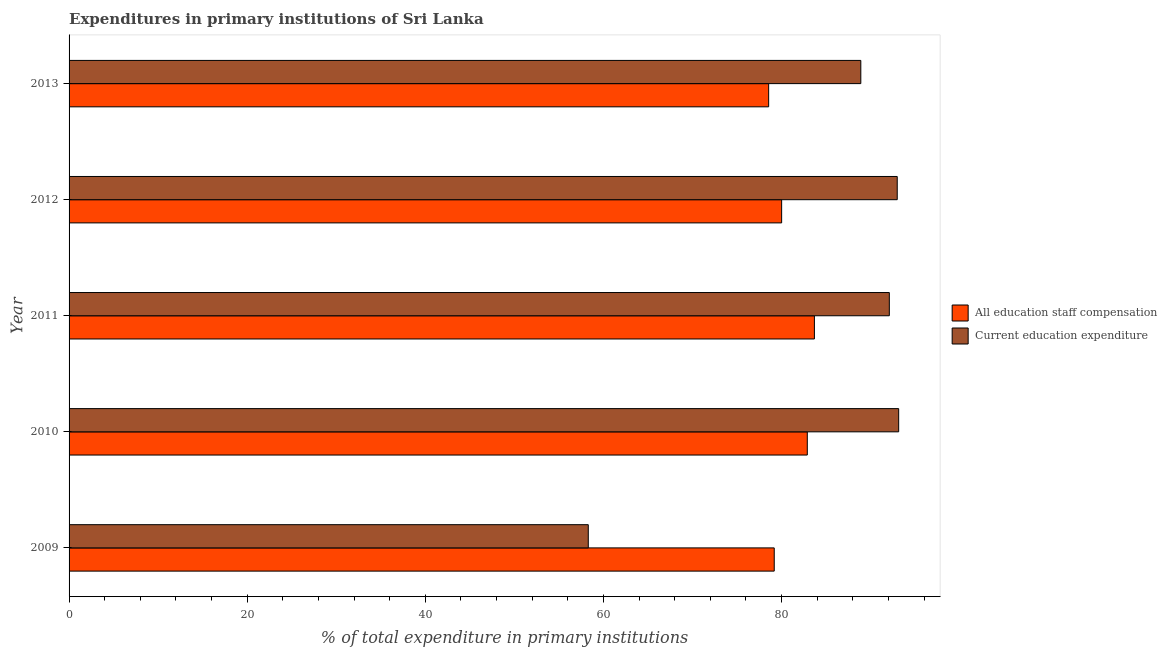How many different coloured bars are there?
Your answer should be compact. 2. How many groups of bars are there?
Offer a very short reply. 5. Are the number of bars per tick equal to the number of legend labels?
Ensure brevity in your answer.  Yes. Are the number of bars on each tick of the Y-axis equal?
Keep it short and to the point. Yes. How many bars are there on the 4th tick from the bottom?
Your answer should be very brief. 2. What is the label of the 4th group of bars from the top?
Your response must be concise. 2010. In how many cases, is the number of bars for a given year not equal to the number of legend labels?
Your answer should be compact. 0. What is the expenditure in staff compensation in 2013?
Offer a very short reply. 78.55. Across all years, what is the maximum expenditure in education?
Provide a succinct answer. 93.14. Across all years, what is the minimum expenditure in staff compensation?
Give a very brief answer. 78.55. What is the total expenditure in staff compensation in the graph?
Your response must be concise. 404.29. What is the difference between the expenditure in education in 2010 and that in 2011?
Your answer should be very brief. 1.05. What is the difference between the expenditure in education in 2012 and the expenditure in staff compensation in 2009?
Give a very brief answer. 13.81. What is the average expenditure in staff compensation per year?
Your answer should be very brief. 80.86. In the year 2011, what is the difference between the expenditure in staff compensation and expenditure in education?
Ensure brevity in your answer.  -8.41. In how many years, is the expenditure in staff compensation greater than 40 %?
Your answer should be compact. 5. What is the ratio of the expenditure in education in 2012 to that in 2013?
Provide a short and direct response. 1.05. Is the expenditure in education in 2011 less than that in 2012?
Provide a short and direct response. Yes. Is the difference between the expenditure in staff compensation in 2010 and 2011 greater than the difference between the expenditure in education in 2010 and 2011?
Your answer should be very brief. No. What is the difference between the highest and the second highest expenditure in education?
Give a very brief answer. 0.16. What is the difference between the highest and the lowest expenditure in education?
Ensure brevity in your answer.  34.85. What does the 1st bar from the top in 2009 represents?
Offer a terse response. Current education expenditure. What does the 1st bar from the bottom in 2012 represents?
Your response must be concise. All education staff compensation. How many bars are there?
Offer a very short reply. 10. Where does the legend appear in the graph?
Give a very brief answer. Center right. How many legend labels are there?
Offer a terse response. 2. How are the legend labels stacked?
Your response must be concise. Vertical. What is the title of the graph?
Your answer should be very brief. Expenditures in primary institutions of Sri Lanka. Does "Exports" appear as one of the legend labels in the graph?
Your answer should be compact. No. What is the label or title of the X-axis?
Offer a very short reply. % of total expenditure in primary institutions. What is the % of total expenditure in primary institutions of All education staff compensation in 2009?
Give a very brief answer. 79.17. What is the % of total expenditure in primary institutions of Current education expenditure in 2009?
Make the answer very short. 58.29. What is the % of total expenditure in primary institutions of All education staff compensation in 2010?
Your response must be concise. 82.88. What is the % of total expenditure in primary institutions of Current education expenditure in 2010?
Your response must be concise. 93.14. What is the % of total expenditure in primary institutions of All education staff compensation in 2011?
Make the answer very short. 83.68. What is the % of total expenditure in primary institutions in Current education expenditure in 2011?
Provide a short and direct response. 92.09. What is the % of total expenditure in primary institutions of All education staff compensation in 2012?
Your answer should be very brief. 80. What is the % of total expenditure in primary institutions of Current education expenditure in 2012?
Offer a very short reply. 92.98. What is the % of total expenditure in primary institutions of All education staff compensation in 2013?
Keep it short and to the point. 78.55. What is the % of total expenditure in primary institutions of Current education expenditure in 2013?
Your answer should be compact. 88.89. Across all years, what is the maximum % of total expenditure in primary institutions of All education staff compensation?
Your answer should be very brief. 83.68. Across all years, what is the maximum % of total expenditure in primary institutions of Current education expenditure?
Provide a succinct answer. 93.14. Across all years, what is the minimum % of total expenditure in primary institutions of All education staff compensation?
Your answer should be compact. 78.55. Across all years, what is the minimum % of total expenditure in primary institutions of Current education expenditure?
Ensure brevity in your answer.  58.29. What is the total % of total expenditure in primary institutions in All education staff compensation in the graph?
Provide a succinct answer. 404.29. What is the total % of total expenditure in primary institutions in Current education expenditure in the graph?
Offer a very short reply. 425.41. What is the difference between the % of total expenditure in primary institutions in All education staff compensation in 2009 and that in 2010?
Your response must be concise. -3.71. What is the difference between the % of total expenditure in primary institutions of Current education expenditure in 2009 and that in 2010?
Give a very brief answer. -34.85. What is the difference between the % of total expenditure in primary institutions of All education staff compensation in 2009 and that in 2011?
Offer a terse response. -4.51. What is the difference between the % of total expenditure in primary institutions in Current education expenditure in 2009 and that in 2011?
Give a very brief answer. -33.8. What is the difference between the % of total expenditure in primary institutions in All education staff compensation in 2009 and that in 2012?
Make the answer very short. -0.83. What is the difference between the % of total expenditure in primary institutions in Current education expenditure in 2009 and that in 2012?
Keep it short and to the point. -34.69. What is the difference between the % of total expenditure in primary institutions of All education staff compensation in 2009 and that in 2013?
Your answer should be compact. 0.63. What is the difference between the % of total expenditure in primary institutions of Current education expenditure in 2009 and that in 2013?
Give a very brief answer. -30.6. What is the difference between the % of total expenditure in primary institutions in All education staff compensation in 2010 and that in 2011?
Keep it short and to the point. -0.8. What is the difference between the % of total expenditure in primary institutions in Current education expenditure in 2010 and that in 2011?
Your answer should be very brief. 1.05. What is the difference between the % of total expenditure in primary institutions of All education staff compensation in 2010 and that in 2012?
Give a very brief answer. 2.88. What is the difference between the % of total expenditure in primary institutions in Current education expenditure in 2010 and that in 2012?
Your answer should be compact. 0.16. What is the difference between the % of total expenditure in primary institutions in All education staff compensation in 2010 and that in 2013?
Make the answer very short. 4.34. What is the difference between the % of total expenditure in primary institutions of Current education expenditure in 2010 and that in 2013?
Your answer should be very brief. 4.25. What is the difference between the % of total expenditure in primary institutions of All education staff compensation in 2011 and that in 2012?
Your response must be concise. 3.68. What is the difference between the % of total expenditure in primary institutions in Current education expenditure in 2011 and that in 2012?
Offer a very short reply. -0.89. What is the difference between the % of total expenditure in primary institutions in All education staff compensation in 2011 and that in 2013?
Offer a terse response. 5.14. What is the difference between the % of total expenditure in primary institutions in Current education expenditure in 2011 and that in 2013?
Ensure brevity in your answer.  3.2. What is the difference between the % of total expenditure in primary institutions of All education staff compensation in 2012 and that in 2013?
Give a very brief answer. 1.46. What is the difference between the % of total expenditure in primary institutions of Current education expenditure in 2012 and that in 2013?
Offer a very short reply. 4.09. What is the difference between the % of total expenditure in primary institutions in All education staff compensation in 2009 and the % of total expenditure in primary institutions in Current education expenditure in 2010?
Keep it short and to the point. -13.97. What is the difference between the % of total expenditure in primary institutions of All education staff compensation in 2009 and the % of total expenditure in primary institutions of Current education expenditure in 2011?
Keep it short and to the point. -12.92. What is the difference between the % of total expenditure in primary institutions in All education staff compensation in 2009 and the % of total expenditure in primary institutions in Current education expenditure in 2012?
Provide a succinct answer. -13.81. What is the difference between the % of total expenditure in primary institutions in All education staff compensation in 2009 and the % of total expenditure in primary institutions in Current education expenditure in 2013?
Offer a terse response. -9.72. What is the difference between the % of total expenditure in primary institutions in All education staff compensation in 2010 and the % of total expenditure in primary institutions in Current education expenditure in 2011?
Make the answer very short. -9.21. What is the difference between the % of total expenditure in primary institutions of All education staff compensation in 2010 and the % of total expenditure in primary institutions of Current education expenditure in 2012?
Your answer should be compact. -10.1. What is the difference between the % of total expenditure in primary institutions of All education staff compensation in 2010 and the % of total expenditure in primary institutions of Current education expenditure in 2013?
Your response must be concise. -6.01. What is the difference between the % of total expenditure in primary institutions in All education staff compensation in 2011 and the % of total expenditure in primary institutions in Current education expenditure in 2012?
Keep it short and to the point. -9.3. What is the difference between the % of total expenditure in primary institutions in All education staff compensation in 2011 and the % of total expenditure in primary institutions in Current education expenditure in 2013?
Make the answer very short. -5.21. What is the difference between the % of total expenditure in primary institutions in All education staff compensation in 2012 and the % of total expenditure in primary institutions in Current education expenditure in 2013?
Offer a terse response. -8.89. What is the average % of total expenditure in primary institutions in All education staff compensation per year?
Offer a very short reply. 80.86. What is the average % of total expenditure in primary institutions in Current education expenditure per year?
Your response must be concise. 85.08. In the year 2009, what is the difference between the % of total expenditure in primary institutions in All education staff compensation and % of total expenditure in primary institutions in Current education expenditure?
Provide a succinct answer. 20.88. In the year 2010, what is the difference between the % of total expenditure in primary institutions of All education staff compensation and % of total expenditure in primary institutions of Current education expenditure?
Ensure brevity in your answer.  -10.26. In the year 2011, what is the difference between the % of total expenditure in primary institutions in All education staff compensation and % of total expenditure in primary institutions in Current education expenditure?
Keep it short and to the point. -8.41. In the year 2012, what is the difference between the % of total expenditure in primary institutions in All education staff compensation and % of total expenditure in primary institutions in Current education expenditure?
Ensure brevity in your answer.  -12.98. In the year 2013, what is the difference between the % of total expenditure in primary institutions of All education staff compensation and % of total expenditure in primary institutions of Current education expenditure?
Give a very brief answer. -10.35. What is the ratio of the % of total expenditure in primary institutions in All education staff compensation in 2009 to that in 2010?
Provide a succinct answer. 0.96. What is the ratio of the % of total expenditure in primary institutions in Current education expenditure in 2009 to that in 2010?
Offer a terse response. 0.63. What is the ratio of the % of total expenditure in primary institutions of All education staff compensation in 2009 to that in 2011?
Provide a short and direct response. 0.95. What is the ratio of the % of total expenditure in primary institutions in Current education expenditure in 2009 to that in 2011?
Ensure brevity in your answer.  0.63. What is the ratio of the % of total expenditure in primary institutions of Current education expenditure in 2009 to that in 2012?
Provide a short and direct response. 0.63. What is the ratio of the % of total expenditure in primary institutions in All education staff compensation in 2009 to that in 2013?
Your answer should be very brief. 1.01. What is the ratio of the % of total expenditure in primary institutions of Current education expenditure in 2009 to that in 2013?
Your answer should be very brief. 0.66. What is the ratio of the % of total expenditure in primary institutions of All education staff compensation in 2010 to that in 2011?
Ensure brevity in your answer.  0.99. What is the ratio of the % of total expenditure in primary institutions in Current education expenditure in 2010 to that in 2011?
Make the answer very short. 1.01. What is the ratio of the % of total expenditure in primary institutions in All education staff compensation in 2010 to that in 2012?
Give a very brief answer. 1.04. What is the ratio of the % of total expenditure in primary institutions of All education staff compensation in 2010 to that in 2013?
Provide a succinct answer. 1.06. What is the ratio of the % of total expenditure in primary institutions in Current education expenditure in 2010 to that in 2013?
Your response must be concise. 1.05. What is the ratio of the % of total expenditure in primary institutions in All education staff compensation in 2011 to that in 2012?
Give a very brief answer. 1.05. What is the ratio of the % of total expenditure in primary institutions in All education staff compensation in 2011 to that in 2013?
Offer a terse response. 1.07. What is the ratio of the % of total expenditure in primary institutions of Current education expenditure in 2011 to that in 2013?
Provide a succinct answer. 1.04. What is the ratio of the % of total expenditure in primary institutions of All education staff compensation in 2012 to that in 2013?
Offer a terse response. 1.02. What is the ratio of the % of total expenditure in primary institutions of Current education expenditure in 2012 to that in 2013?
Provide a succinct answer. 1.05. What is the difference between the highest and the second highest % of total expenditure in primary institutions in All education staff compensation?
Offer a very short reply. 0.8. What is the difference between the highest and the second highest % of total expenditure in primary institutions in Current education expenditure?
Offer a terse response. 0.16. What is the difference between the highest and the lowest % of total expenditure in primary institutions of All education staff compensation?
Your answer should be compact. 5.14. What is the difference between the highest and the lowest % of total expenditure in primary institutions of Current education expenditure?
Make the answer very short. 34.85. 